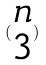<formula> <loc_0><loc_0><loc_500><loc_500>( \begin{matrix} n \\ 3 \end{matrix} )</formula> 